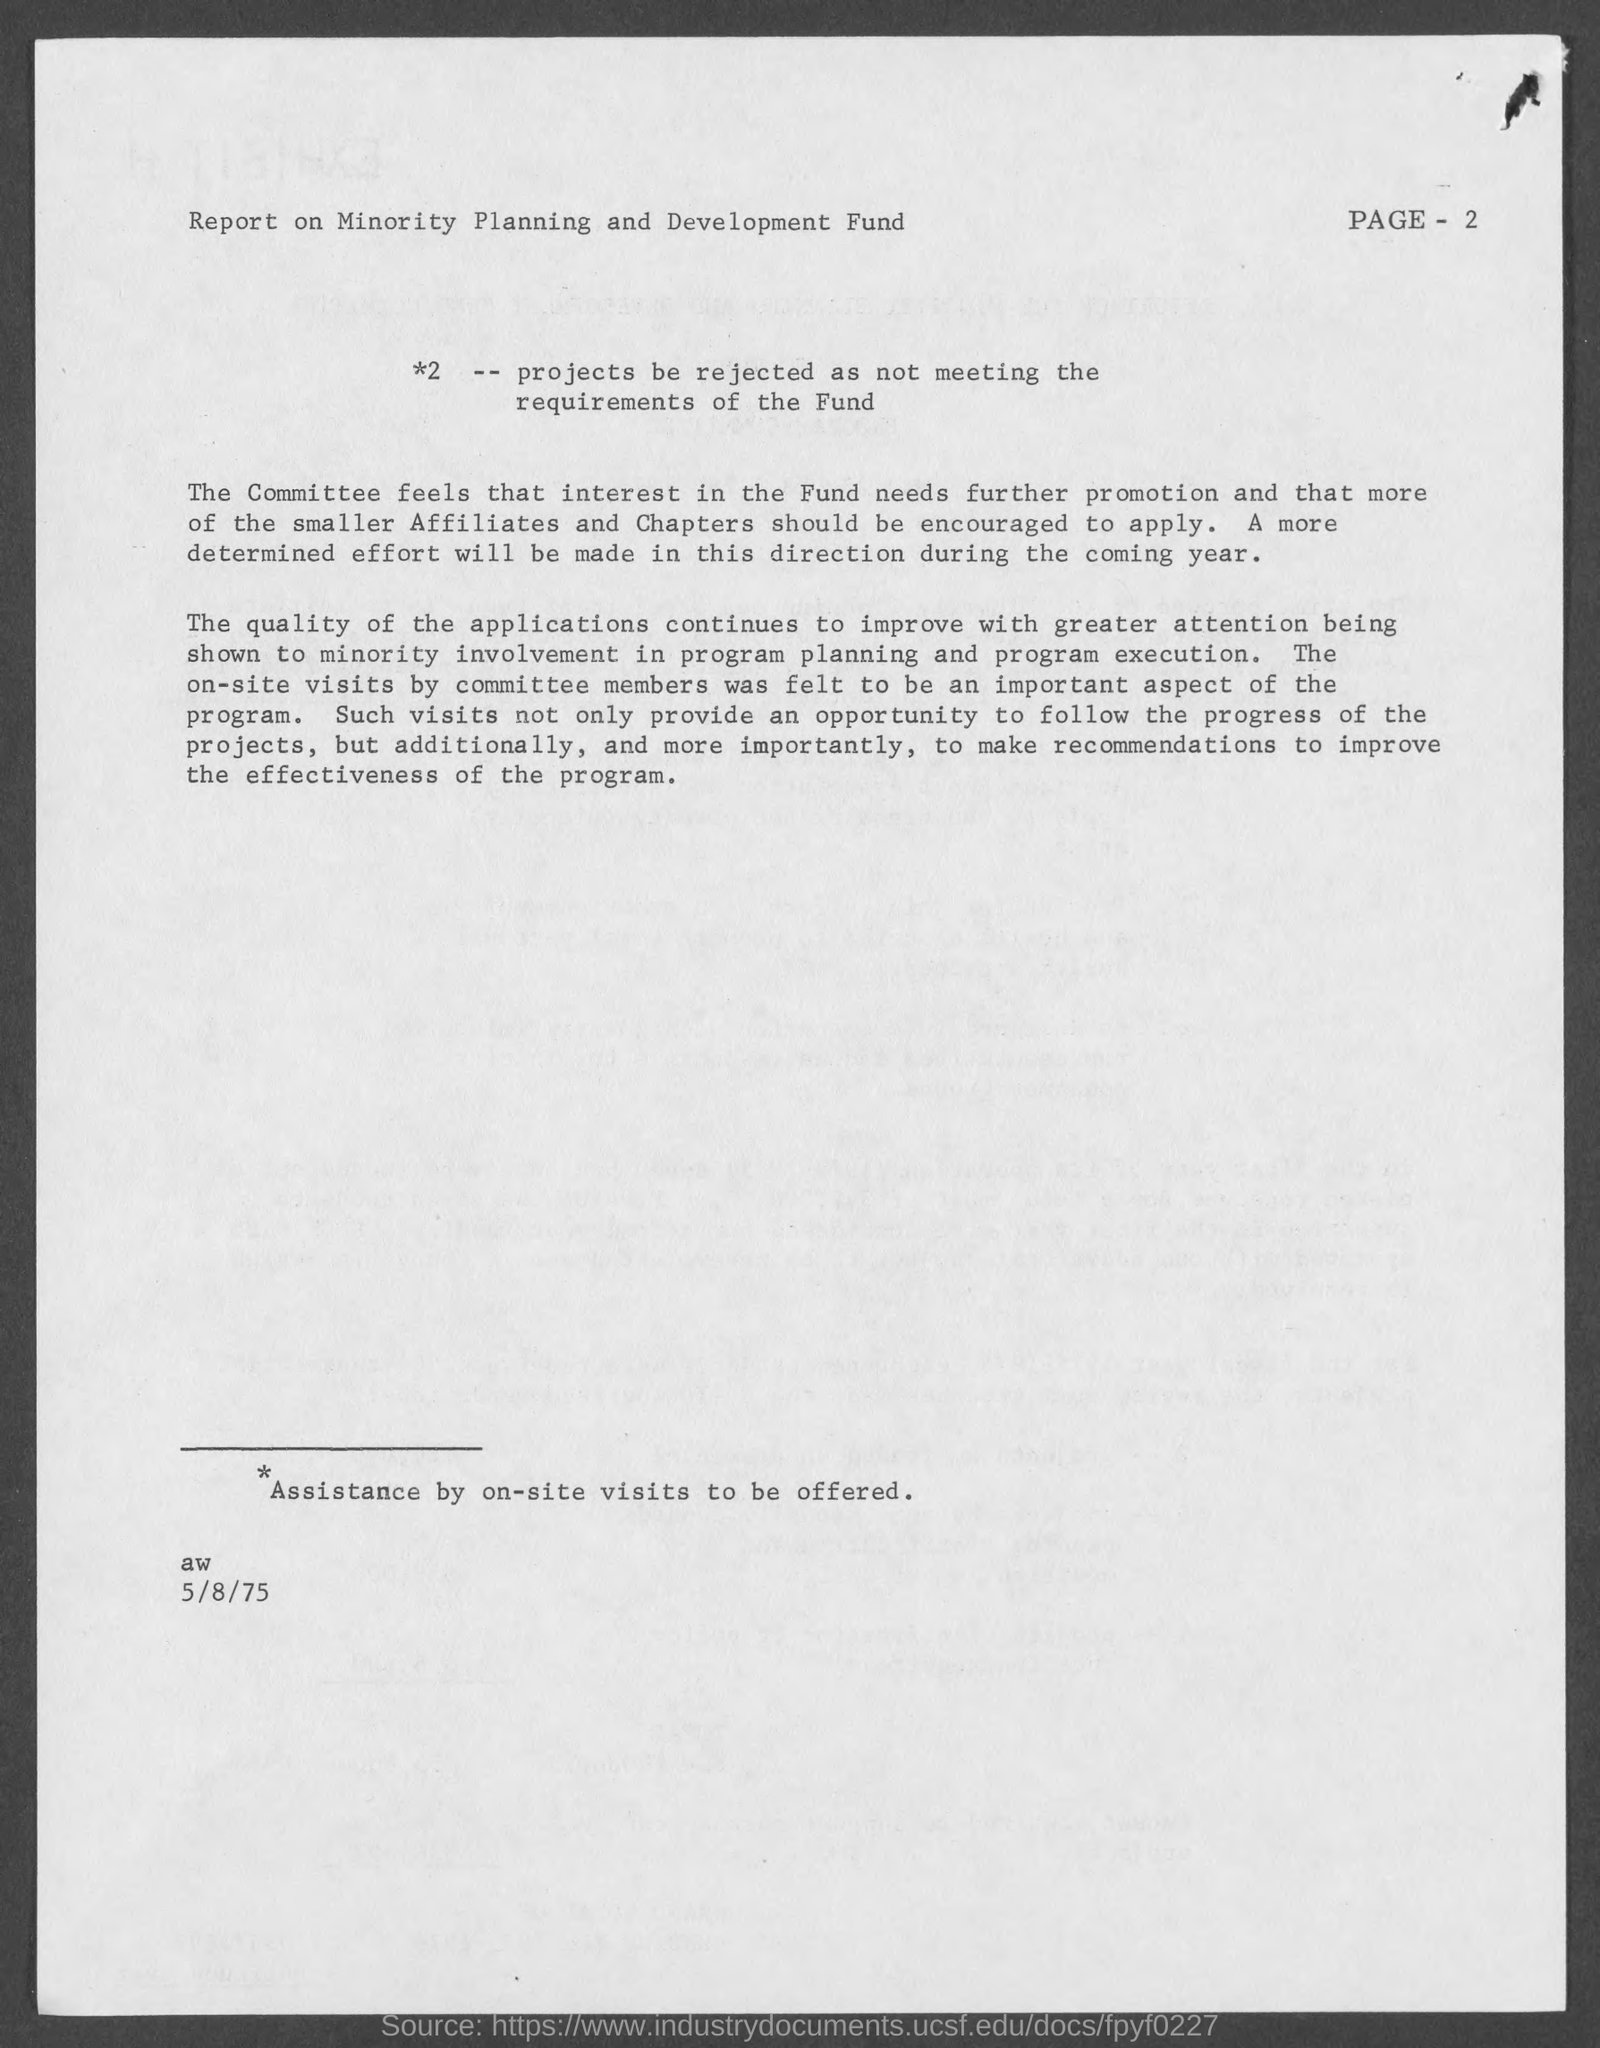What is the date mentioned in this document?
Keep it short and to the point. 5/8/75. 